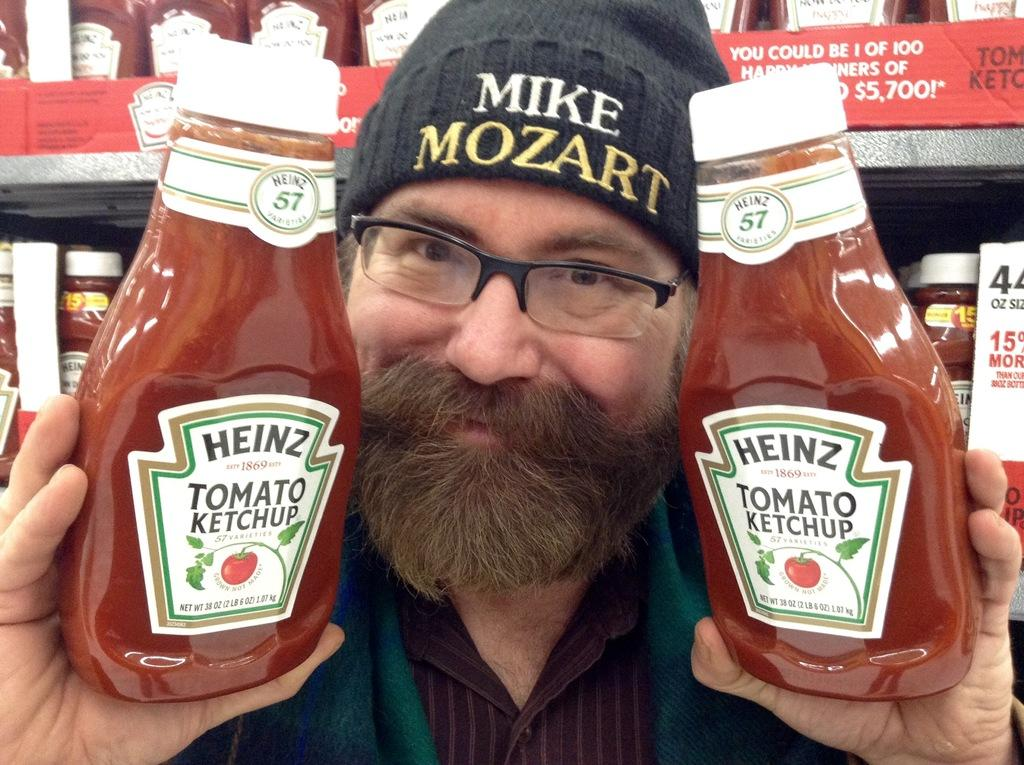Who is in the image? There is a person in the image. What is the person holding? The person is holding ketchup bottles. What is the person's facial expression? The person is smiling. What can be seen in the background of the image? There is a shelf with jars visible in the background of the image. What type of milk is being poured into the ketchup bottles in the image? There is no milk being poured into the ketchup bottles in the image; the person is simply holding them. 